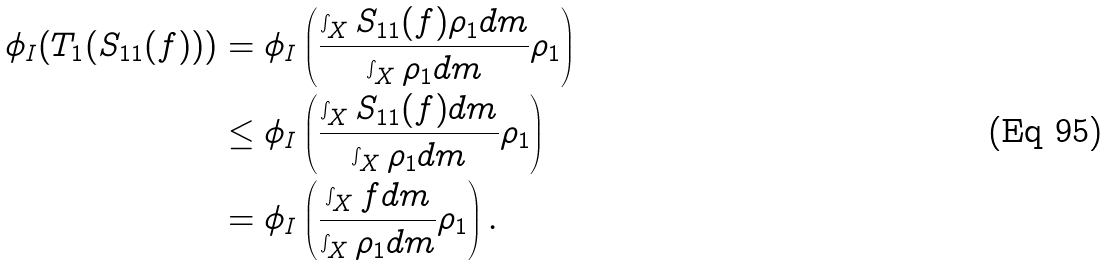Convert formula to latex. <formula><loc_0><loc_0><loc_500><loc_500>\phi _ { I } ( T _ { 1 } ( S _ { 1 1 } ( f ) ) ) & = \phi _ { I } \left ( \frac { \int _ { X } S _ { 1 1 } ( f ) \rho _ { 1 } d m } { \int _ { X } \rho _ { 1 } d m } \rho _ { 1 } \right ) \\ & \leq \phi _ { I } \left ( \frac { \int _ { X } S _ { 1 1 } ( f ) d m } { \int _ { X } \rho _ { 1 } d m } \rho _ { 1 } \right ) \\ & = \phi _ { I } \left ( \frac { \int _ { X } f d m } { \int _ { X } \rho _ { 1 } d m } \rho _ { 1 } \right ) .</formula> 